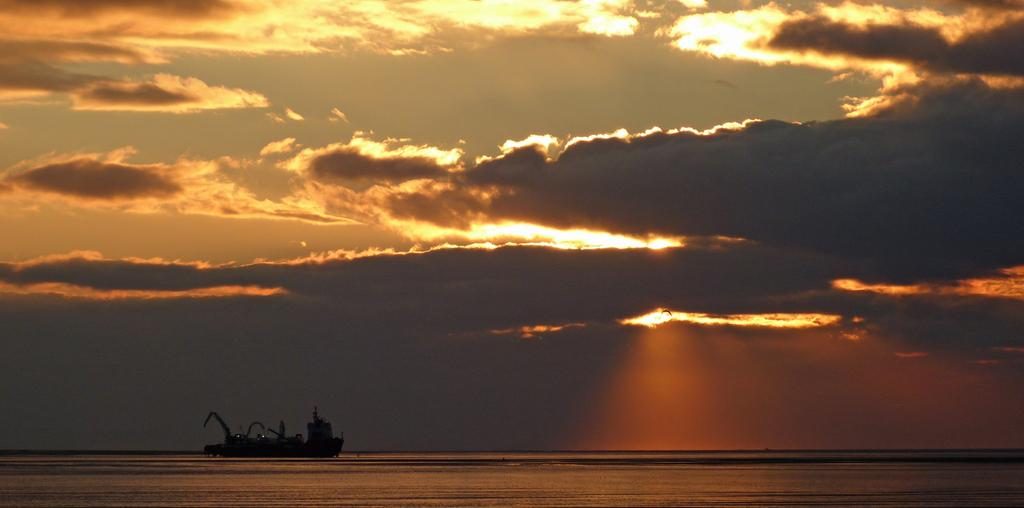What is the main subject of the picture? The main subject of the picture is a ship in the water. What can be seen in the background of the image? There is a sky visible in the background, with clouds and sunshine. What is the color of the clouds in the image? The clouds are black in color. Can you describe the weather conditions in the image? The presence of black clouds and sunshine suggests that there might be a storm or heavy rain in the area. What type of approval is required for the ship to set sail in the image? There is no information about approval or sailing requirements in the image, so it cannot be determined from the picture. 